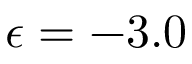<formula> <loc_0><loc_0><loc_500><loc_500>\epsilon = - 3 . 0</formula> 